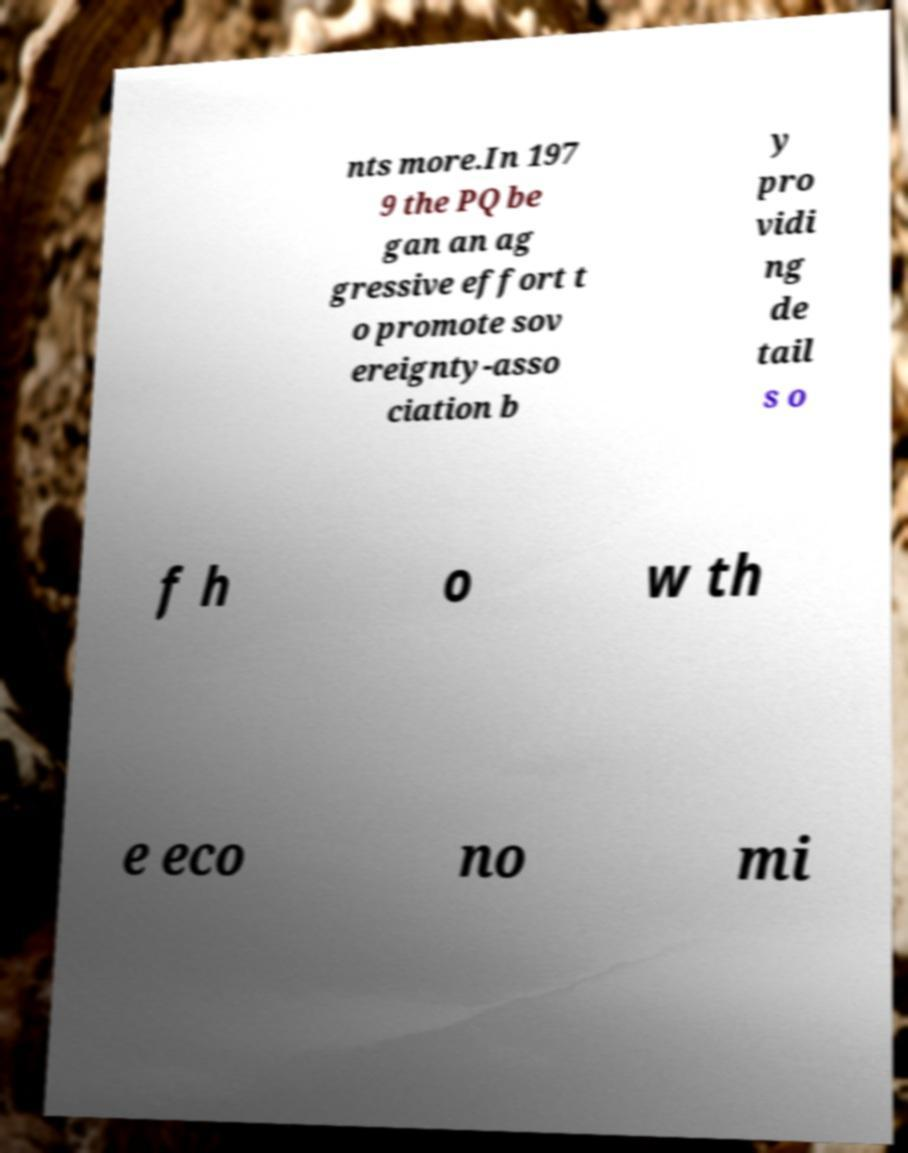For documentation purposes, I need the text within this image transcribed. Could you provide that? nts more.In 197 9 the PQ be gan an ag gressive effort t o promote sov ereignty-asso ciation b y pro vidi ng de tail s o f h o w th e eco no mi 